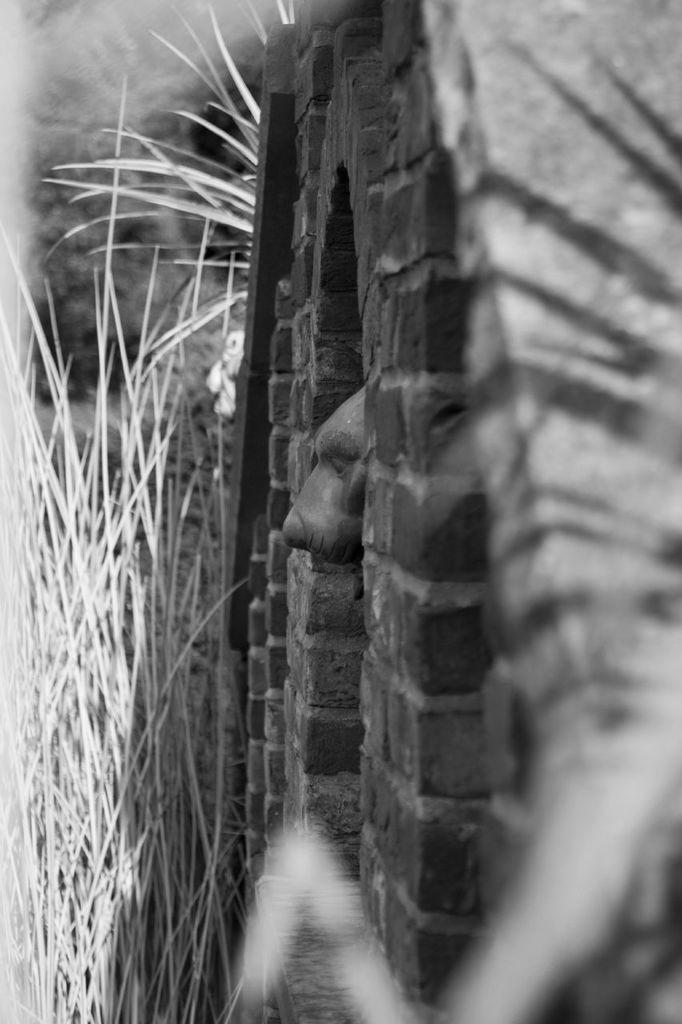What is the color scheme of the image? The image is black and white. What animal can be seen in the image? There is a dog in the image. How is the dog positioned in relation to the stone wall? The dog has its head out from a stone wall. What type of vegetation is visible in the image? There is grass visible in the image. What type of sound can be heard coming from the dog in the image? There is no sound present in the image, as it is a still photograph. What scene is depicted in the image? The image depicts a dog with its head out from a stone wall, with grass visible in the background. 